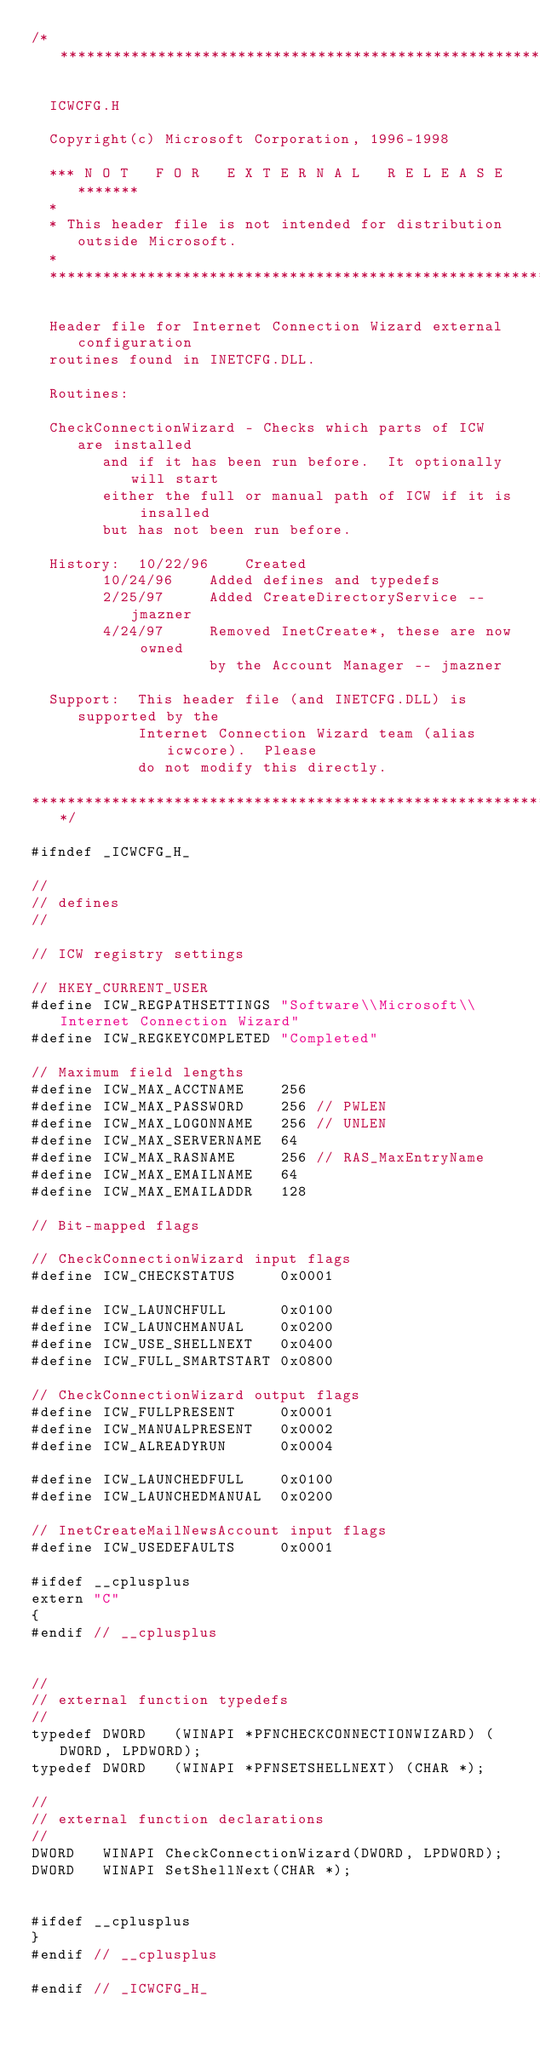Convert code to text. <code><loc_0><loc_0><loc_500><loc_500><_C_>/********************************************************************

  ICWCFG.H

  Copyright(c) Microsoft Corporation, 1996-1998

  *** N O T   F O R   E X T E R N A L   R E L E A S E *******
  *
  * This header file is not intended for distribution outside Microsoft.
  *
  ***********************************************************

  Header file for Internet Connection Wizard external configuration
  routines found in INETCFG.DLL.

  Routines:

  CheckConnectionWizard - Checks which parts of ICW are installed
		and if it has been run before.  It optionally will start
		either the full or manual path of ICW if it is insalled
		but has not been run before.

  History:	10/22/96	Created
		10/24/96	Added defines and typedefs
		2/25/97		Added CreateDirectoryService -- jmazner
		4/24/97		Removed InetCreate*, these are now owned
					by the Account Manager -- jmazner

  Support:	This header file (and INETCFG.DLL) is supported by the
			Internet Connection Wizard team (alias icwcore).  Please
			do not modify this directly.

*********************************************************************/

#ifndef _ICWCFG_H_

//
// defines
//

// ICW registry settings

// HKEY_CURRENT_USER
#define ICW_REGPATHSETTINGS	"Software\\Microsoft\\Internet Connection Wizard"
#define ICW_REGKEYCOMPLETED	"Completed"

// Maximum field lengths
#define ICW_MAX_ACCTNAME	256
#define ICW_MAX_PASSWORD	256	// PWLEN
#define ICW_MAX_LOGONNAME	256	// UNLEN
#define ICW_MAX_SERVERNAME	64
#define ICW_MAX_RASNAME		256	// RAS_MaxEntryName
#define ICW_MAX_EMAILNAME	64
#define ICW_MAX_EMAILADDR	128

// Bit-mapped flags

// CheckConnectionWizard input flags
#define ICW_CHECKSTATUS		0x0001

#define ICW_LAUNCHFULL		0x0100
#define ICW_LAUNCHMANUAL	0x0200
#define ICW_USE_SHELLNEXT	0x0400
#define ICW_FULL_SMARTSTART	0x0800

// CheckConnectionWizard output flags
#define ICW_FULLPRESENT		0x0001
#define ICW_MANUALPRESENT	0x0002
#define ICW_ALREADYRUN		0x0004

#define ICW_LAUNCHEDFULL	0x0100
#define ICW_LAUNCHEDMANUAL	0x0200

// InetCreateMailNewsAccount input flags
#define ICW_USEDEFAULTS		0x0001

#ifdef __cplusplus
extern "C"
{
#endif // __cplusplus


//
// external function typedefs
//
typedef DWORD	(WINAPI *PFNCHECKCONNECTIONWIZARD) (DWORD, LPDWORD);
typedef DWORD	(WINAPI *PFNSETSHELLNEXT) (CHAR *);

//
// external function declarations
//
DWORD	WINAPI CheckConnectionWizard(DWORD, LPDWORD);
DWORD	WINAPI SetShellNext(CHAR *);


#ifdef __cplusplus
}
#endif // __cplusplus

#endif // _ICWCFG_H_</code> 